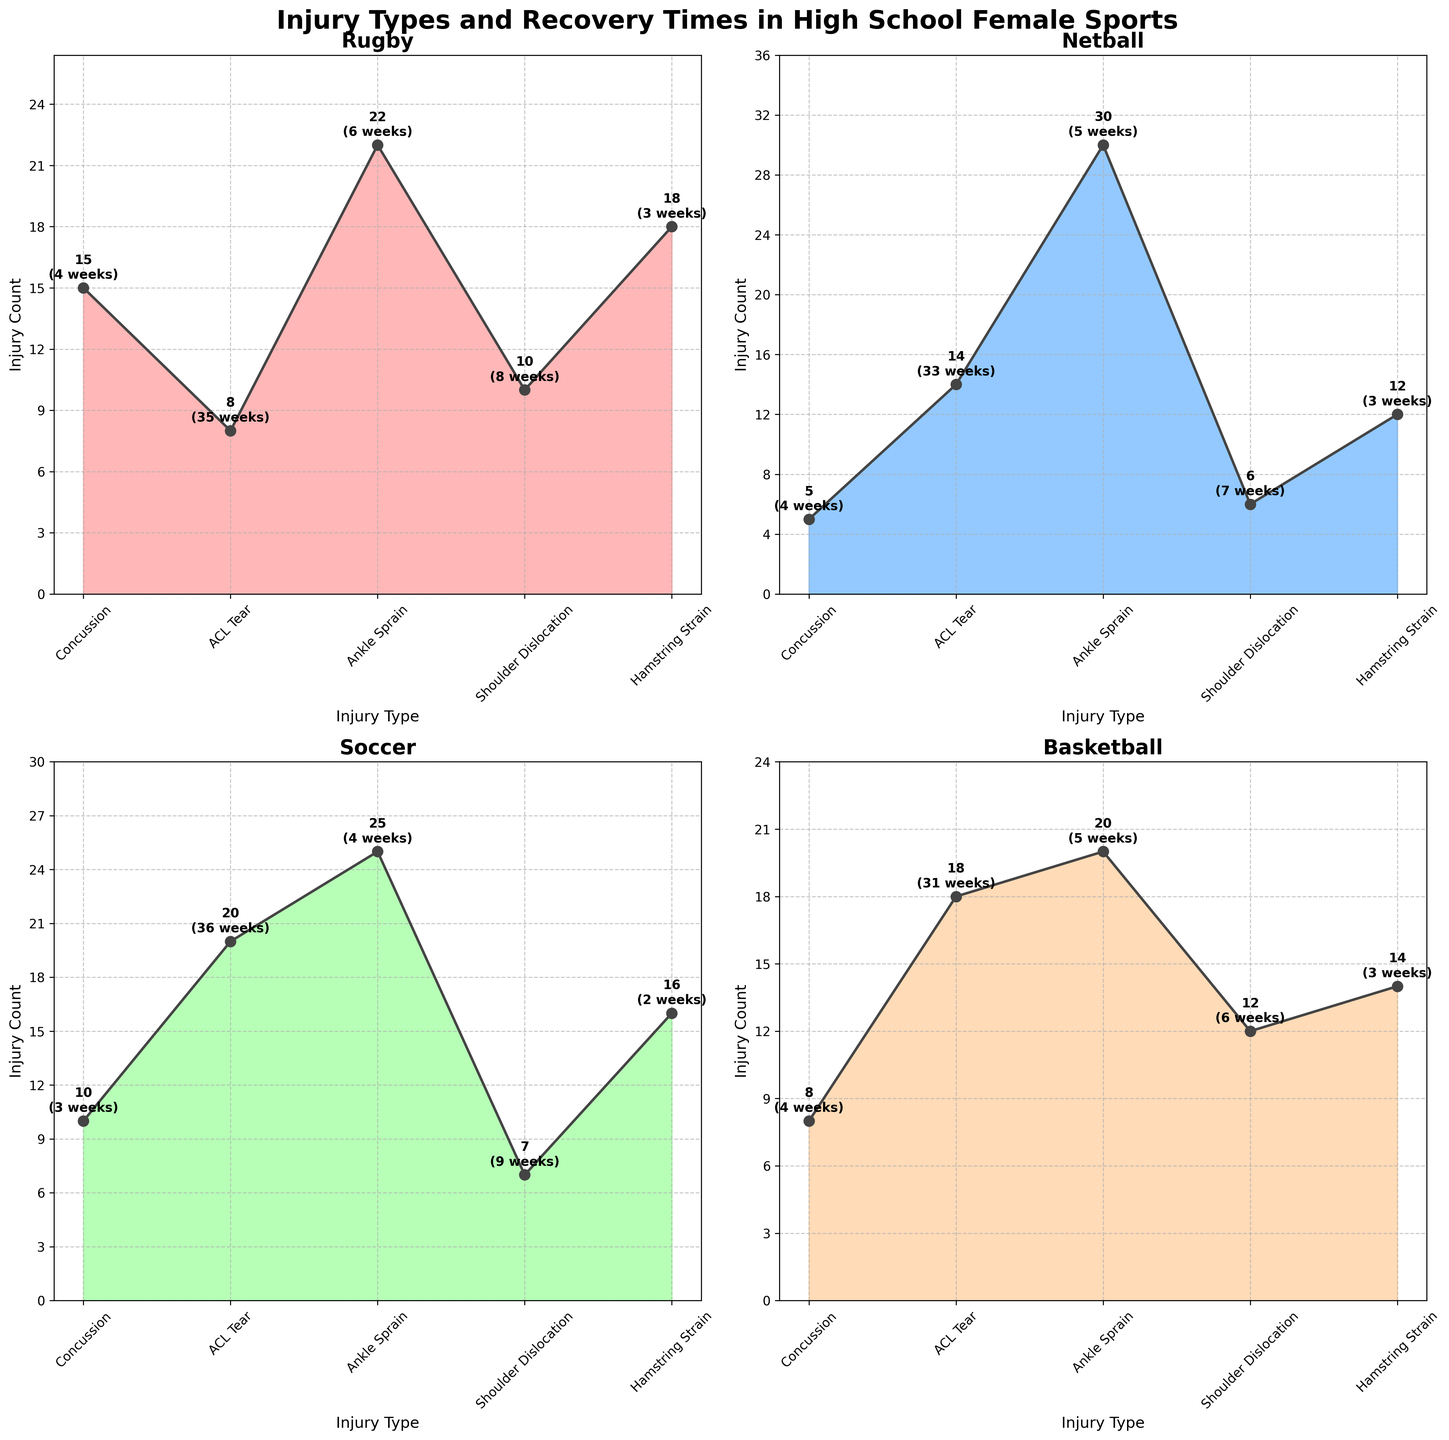What sport has the highest count of ankle sprains? The plot shows that Netball has an ankle sprain count of 30, which is the highest among the four sports.
Answer: Netball Which injury type has the longest average recovery time in Rugby? From the Rugby subplot, ACL Tear has the longest average recovery time of 35 weeks.
Answer: ACL Tear Compare the frequency of concussions in Rugby and Basketball. Which sport has a higher count? Rugby has 15 concussions while Basketball has 8. Therefore, Rugby has a higher count.
Answer: Rugby What is the total number of injuries for Soccer? Summing all the injury counts for Soccer: Concussion (10) + ACL Tear (20) + Ankle Sprain (25) + Shoulder Dislocation (7) + Hamstring Strain (16) = 78.
Answer: 78 Among the four sports, which one has the least frequent shoulder dislocation? Netball has 6 shoulder dislocations, which is the least among the four sports.
Answer: Netball Which sport has the shortest average recovery time for Hamstring Strain? Soccer has the shortest average recovery time for Hamstring Strain, which is 2 weeks.
Answer: Soccer Compare the recovery times for ACL Tears in all four sports. List them in descending order. The recovery times for ACL Tears are 36 weeks (Soccer), 35 weeks (Rugby), 33 weeks (Netball), and 31 weeks (Basketball).
Answer: Soccer, Rugby, Netball, Basketball Which injury type appears most frequently overall when combining data from all sports? Summing the injury counts for each type across all sports, Ankle Sprain has the highest total count.
Answer: Ankle Sprain How many more ACL Tear injuries are there in Soccer than in Rugby? Soccer has 20 ACL Tear injuries, and Rugby has 8. The difference is 20 - 8 = 12.
Answer: 12 Which type of injury has a similar recovery time in Rugby and Netball? Concussion has a similar recovery time in both Rugby and Netball, which is 4 weeks.
Answer: Concussion 